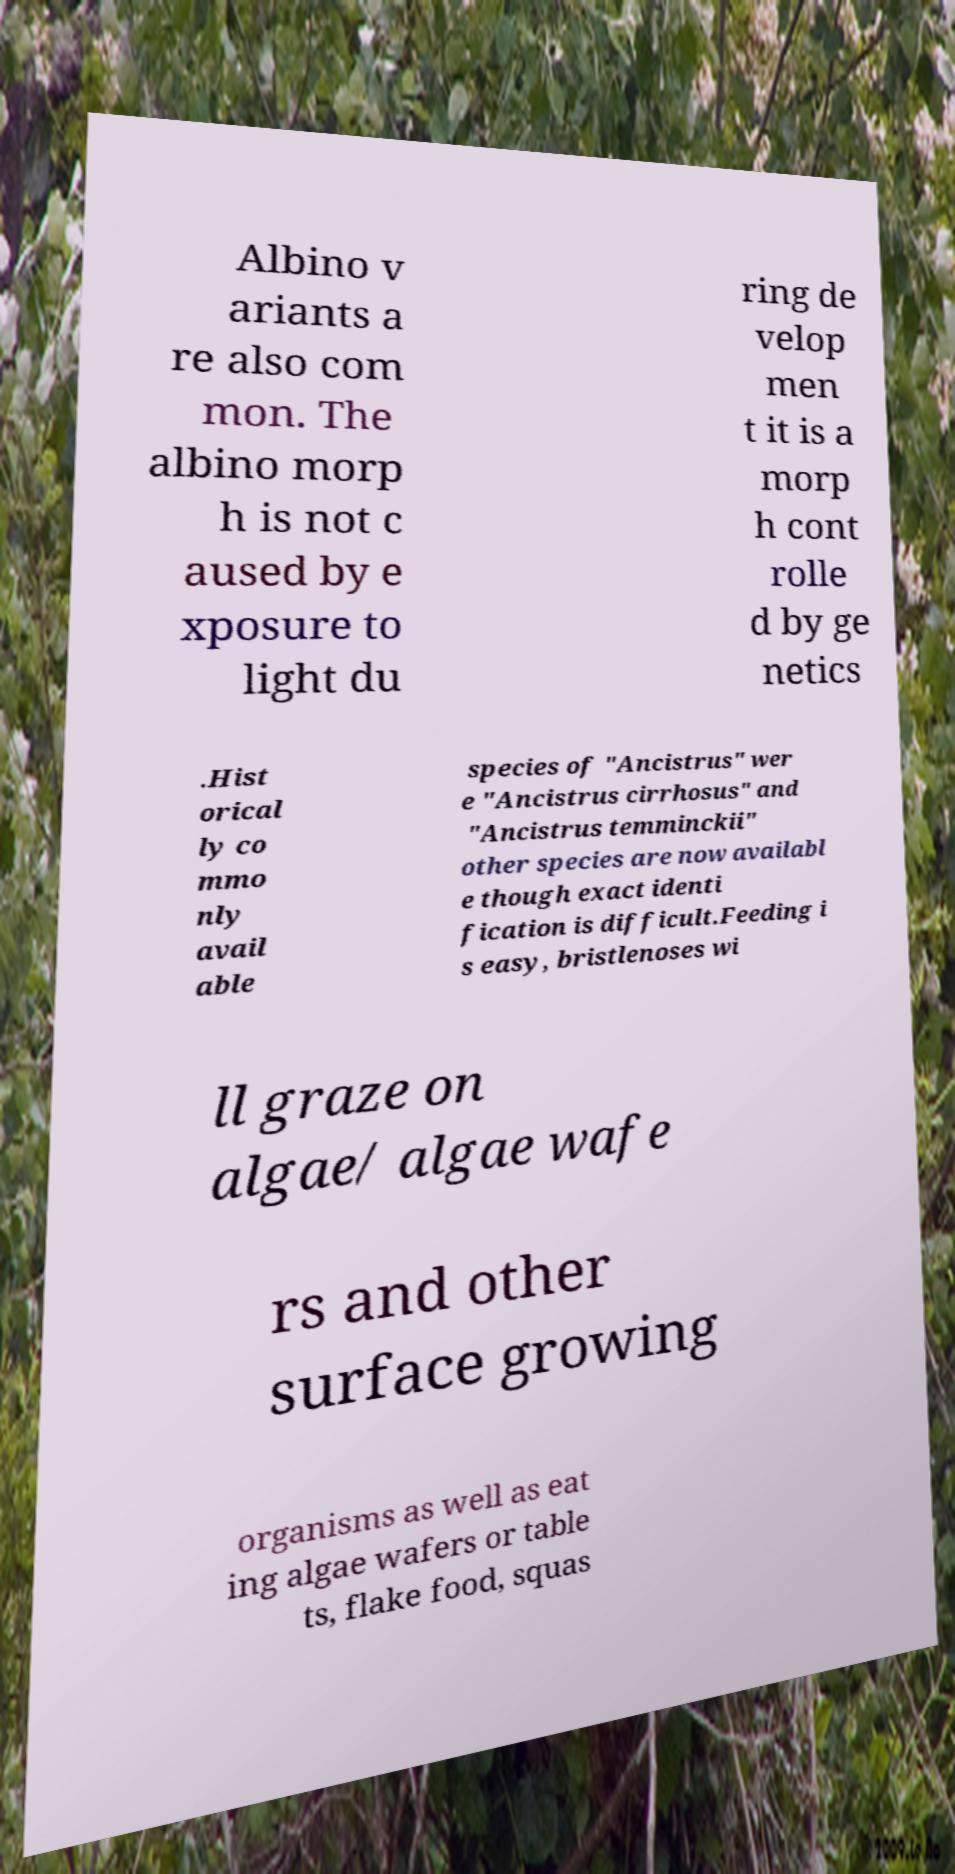What messages or text are displayed in this image? I need them in a readable, typed format. Albino v ariants a re also com mon. The albino morp h is not c aused by e xposure to light du ring de velop men t it is a morp h cont rolle d by ge netics .Hist orical ly co mmo nly avail able species of "Ancistrus" wer e "Ancistrus cirrhosus" and "Ancistrus temminckii" other species are now availabl e though exact identi fication is difficult.Feeding i s easy, bristlenoses wi ll graze on algae/ algae wafe rs and other surface growing organisms as well as eat ing algae wafers or table ts, flake food, squas 